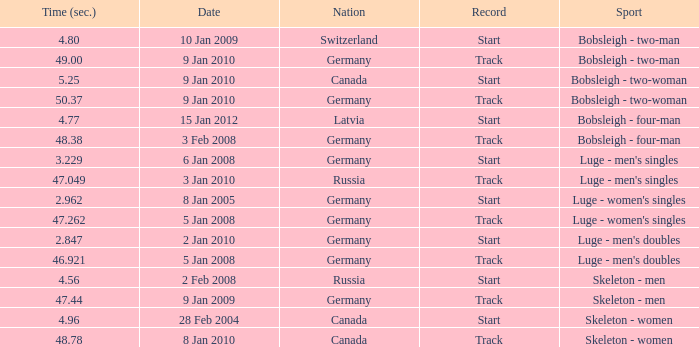Which nation recorded a time of 4 Germany. 